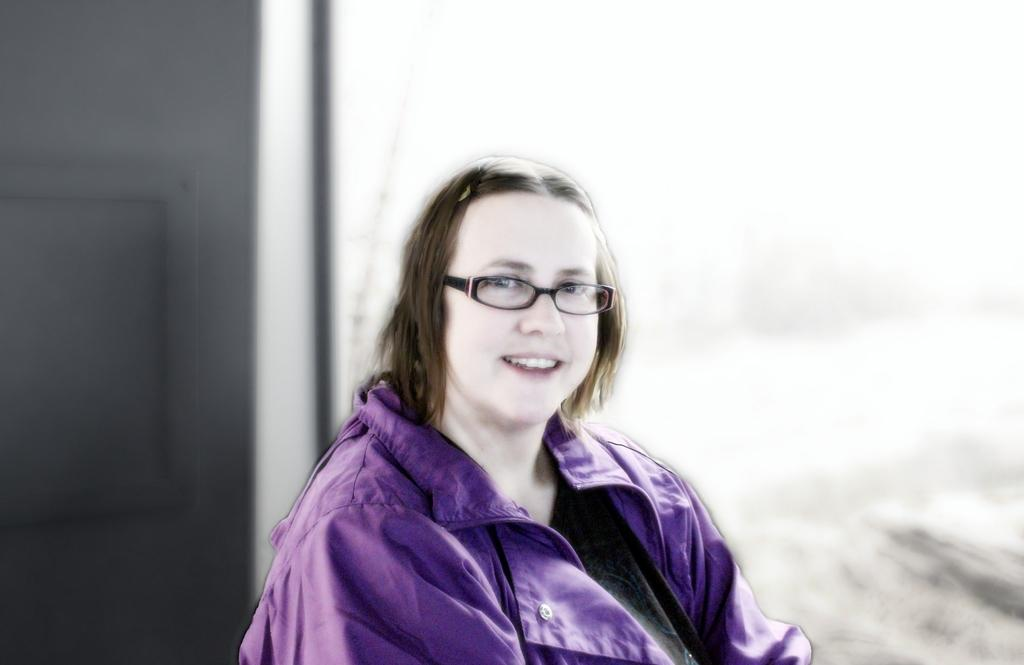Who is the main subject in the image? There is a woman in the image. What is the woman wearing in the image? The woman is wearing a purple jacket and spectacles. Can you describe the background of the image? The background of the image is blurred. Where is the shelf located in the image? There is no shelf present in the image. What type of hammer is the woman using in the image? There is no hammer present in the image. 